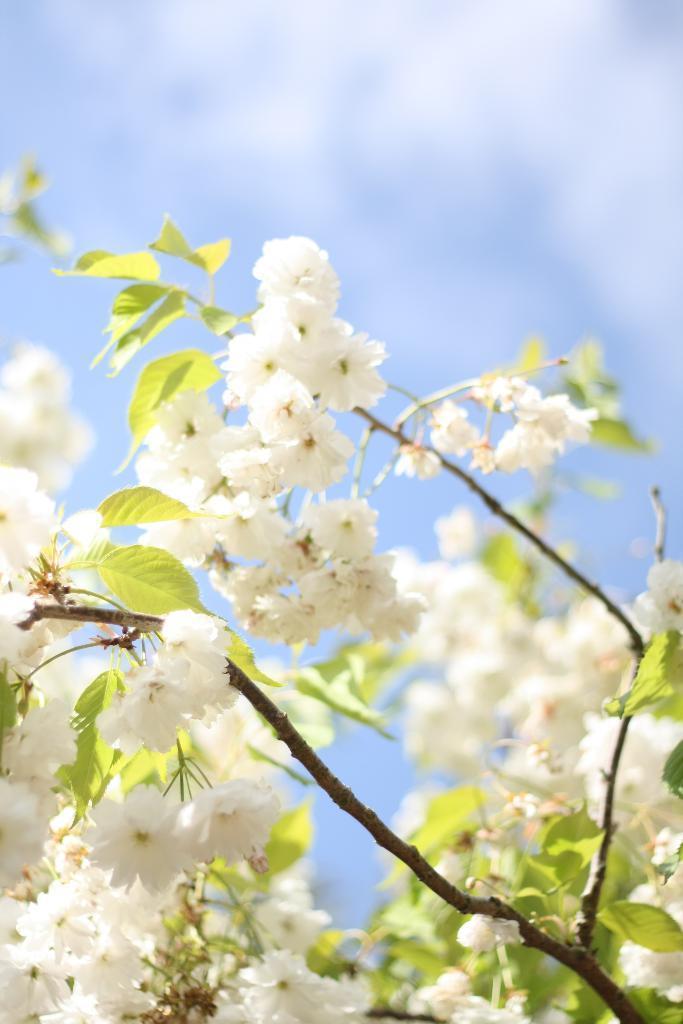Could you give a brief overview of what you see in this image? In this image there are white color flowers and leaves. There are stems. 